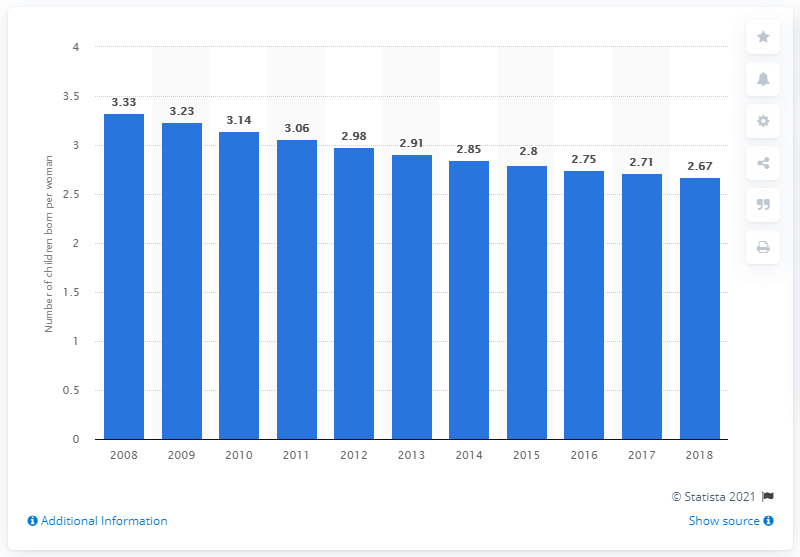Identify some key points in this picture. The fertility rate in Laos in 2018 was 2.67. 